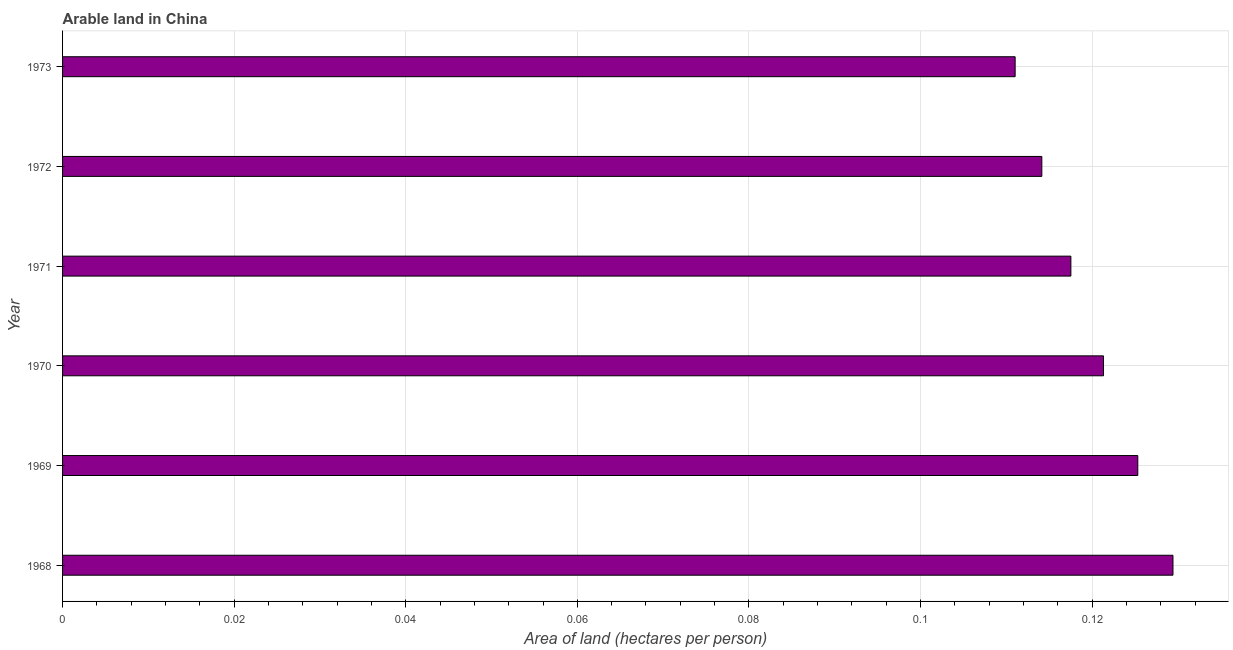What is the title of the graph?
Provide a short and direct response. Arable land in China. What is the label or title of the X-axis?
Make the answer very short. Area of land (hectares per person). What is the area of arable land in 1969?
Make the answer very short. 0.13. Across all years, what is the maximum area of arable land?
Ensure brevity in your answer.  0.13. Across all years, what is the minimum area of arable land?
Your answer should be very brief. 0.11. In which year was the area of arable land maximum?
Make the answer very short. 1968. What is the sum of the area of arable land?
Ensure brevity in your answer.  0.72. What is the difference between the area of arable land in 1971 and 1973?
Provide a succinct answer. 0.01. What is the average area of arable land per year?
Offer a terse response. 0.12. What is the median area of arable land?
Give a very brief answer. 0.12. Do a majority of the years between 1969 and 1970 (inclusive) have area of arable land greater than 0.056 hectares per person?
Ensure brevity in your answer.  Yes. What is the ratio of the area of arable land in 1968 to that in 1971?
Provide a short and direct response. 1.1. Is the area of arable land in 1968 less than that in 1973?
Make the answer very short. No. Is the difference between the area of arable land in 1970 and 1971 greater than the difference between any two years?
Your answer should be compact. No. What is the difference between the highest and the second highest area of arable land?
Offer a terse response. 0. How many bars are there?
Provide a short and direct response. 6. Are all the bars in the graph horizontal?
Keep it short and to the point. Yes. How many years are there in the graph?
Your answer should be very brief. 6. Are the values on the major ticks of X-axis written in scientific E-notation?
Offer a terse response. No. What is the Area of land (hectares per person) of 1968?
Provide a succinct answer. 0.13. What is the Area of land (hectares per person) in 1969?
Your response must be concise. 0.13. What is the Area of land (hectares per person) of 1970?
Your answer should be very brief. 0.12. What is the Area of land (hectares per person) in 1971?
Keep it short and to the point. 0.12. What is the Area of land (hectares per person) in 1972?
Give a very brief answer. 0.11. What is the Area of land (hectares per person) in 1973?
Offer a very short reply. 0.11. What is the difference between the Area of land (hectares per person) in 1968 and 1969?
Your response must be concise. 0. What is the difference between the Area of land (hectares per person) in 1968 and 1970?
Keep it short and to the point. 0.01. What is the difference between the Area of land (hectares per person) in 1968 and 1971?
Make the answer very short. 0.01. What is the difference between the Area of land (hectares per person) in 1968 and 1972?
Make the answer very short. 0.02. What is the difference between the Area of land (hectares per person) in 1968 and 1973?
Your response must be concise. 0.02. What is the difference between the Area of land (hectares per person) in 1969 and 1970?
Give a very brief answer. 0. What is the difference between the Area of land (hectares per person) in 1969 and 1971?
Offer a terse response. 0.01. What is the difference between the Area of land (hectares per person) in 1969 and 1972?
Provide a succinct answer. 0.01. What is the difference between the Area of land (hectares per person) in 1969 and 1973?
Your response must be concise. 0.01. What is the difference between the Area of land (hectares per person) in 1970 and 1971?
Your answer should be compact. 0. What is the difference between the Area of land (hectares per person) in 1970 and 1972?
Keep it short and to the point. 0.01. What is the difference between the Area of land (hectares per person) in 1970 and 1973?
Offer a terse response. 0.01. What is the difference between the Area of land (hectares per person) in 1971 and 1972?
Make the answer very short. 0. What is the difference between the Area of land (hectares per person) in 1971 and 1973?
Provide a succinct answer. 0.01. What is the difference between the Area of land (hectares per person) in 1972 and 1973?
Make the answer very short. 0. What is the ratio of the Area of land (hectares per person) in 1968 to that in 1969?
Your answer should be very brief. 1.03. What is the ratio of the Area of land (hectares per person) in 1968 to that in 1970?
Your answer should be compact. 1.07. What is the ratio of the Area of land (hectares per person) in 1968 to that in 1971?
Your answer should be compact. 1.1. What is the ratio of the Area of land (hectares per person) in 1968 to that in 1972?
Your answer should be very brief. 1.13. What is the ratio of the Area of land (hectares per person) in 1968 to that in 1973?
Your response must be concise. 1.17. What is the ratio of the Area of land (hectares per person) in 1969 to that in 1970?
Keep it short and to the point. 1.03. What is the ratio of the Area of land (hectares per person) in 1969 to that in 1971?
Provide a short and direct response. 1.07. What is the ratio of the Area of land (hectares per person) in 1969 to that in 1972?
Provide a succinct answer. 1.1. What is the ratio of the Area of land (hectares per person) in 1969 to that in 1973?
Provide a succinct answer. 1.13. What is the ratio of the Area of land (hectares per person) in 1970 to that in 1971?
Keep it short and to the point. 1.03. What is the ratio of the Area of land (hectares per person) in 1970 to that in 1972?
Your response must be concise. 1.06. What is the ratio of the Area of land (hectares per person) in 1970 to that in 1973?
Make the answer very short. 1.09. What is the ratio of the Area of land (hectares per person) in 1971 to that in 1972?
Keep it short and to the point. 1.03. What is the ratio of the Area of land (hectares per person) in 1971 to that in 1973?
Give a very brief answer. 1.06. What is the ratio of the Area of land (hectares per person) in 1972 to that in 1973?
Ensure brevity in your answer.  1.03. 